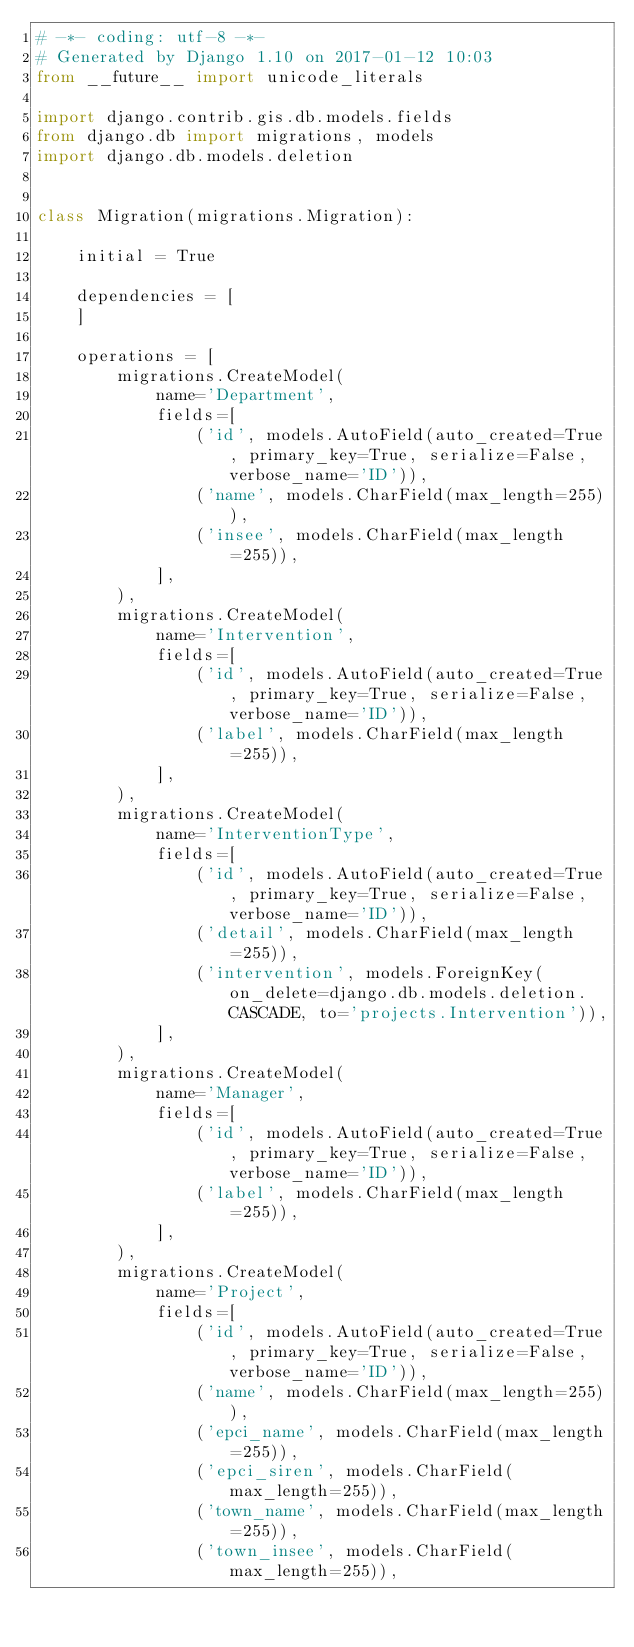<code> <loc_0><loc_0><loc_500><loc_500><_Python_># -*- coding: utf-8 -*-
# Generated by Django 1.10 on 2017-01-12 10:03
from __future__ import unicode_literals

import django.contrib.gis.db.models.fields
from django.db import migrations, models
import django.db.models.deletion


class Migration(migrations.Migration):

    initial = True

    dependencies = [
    ]

    operations = [
        migrations.CreateModel(
            name='Department',
            fields=[
                ('id', models.AutoField(auto_created=True, primary_key=True, serialize=False, verbose_name='ID')),
                ('name', models.CharField(max_length=255)),
                ('insee', models.CharField(max_length=255)),
            ],
        ),
        migrations.CreateModel(
            name='Intervention',
            fields=[
                ('id', models.AutoField(auto_created=True, primary_key=True, serialize=False, verbose_name='ID')),
                ('label', models.CharField(max_length=255)),
            ],
        ),
        migrations.CreateModel(
            name='InterventionType',
            fields=[
                ('id', models.AutoField(auto_created=True, primary_key=True, serialize=False, verbose_name='ID')),
                ('detail', models.CharField(max_length=255)),
                ('intervention', models.ForeignKey(on_delete=django.db.models.deletion.CASCADE, to='projects.Intervention')),
            ],
        ),
        migrations.CreateModel(
            name='Manager',
            fields=[
                ('id', models.AutoField(auto_created=True, primary_key=True, serialize=False, verbose_name='ID')),
                ('label', models.CharField(max_length=255)),
            ],
        ),
        migrations.CreateModel(
            name='Project',
            fields=[
                ('id', models.AutoField(auto_created=True, primary_key=True, serialize=False, verbose_name='ID')),
                ('name', models.CharField(max_length=255)),
                ('epci_name', models.CharField(max_length=255)),
                ('epci_siren', models.CharField(max_length=255)),
                ('town_name', models.CharField(max_length=255)),
                ('town_insee', models.CharField(max_length=255)),</code> 